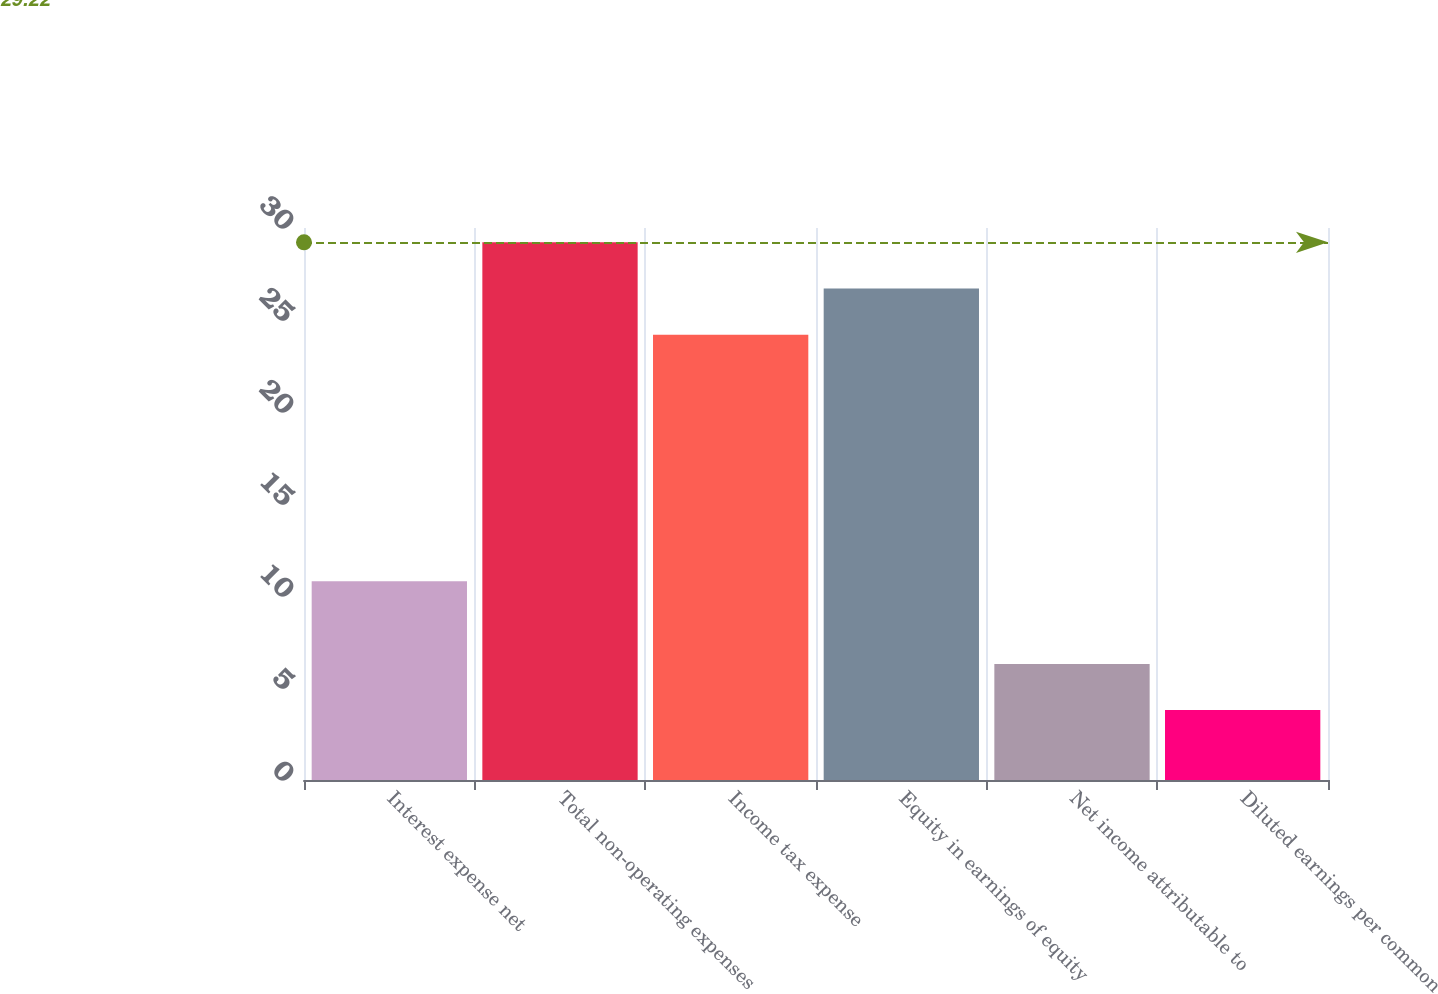Convert chart to OTSL. <chart><loc_0><loc_0><loc_500><loc_500><bar_chart><fcel>Interest expense net<fcel>Total non-operating expenses<fcel>Income tax expense<fcel>Equity in earnings of equity<fcel>Net income attributable to<fcel>Diluted earnings per common<nl><fcel>10.8<fcel>29.22<fcel>24.2<fcel>26.71<fcel>6.31<fcel>3.8<nl></chart> 